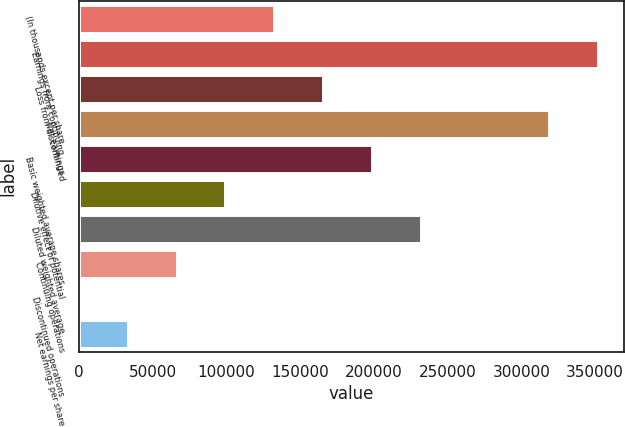Convert chart. <chart><loc_0><loc_0><loc_500><loc_500><bar_chart><fcel>(In thousands except per share<fcel>Earnings from continuing<fcel>Loss from discontinued<fcel>Net earnings<fcel>Basic weighted average shares<fcel>Dilutive effect of potential<fcel>Diluted weighted average<fcel>Continuing operations<fcel>Discontinued operations<fcel>Net earnings per share<nl><fcel>132590<fcel>352170<fcel>165738<fcel>319022<fcel>198886<fcel>99442.9<fcel>232033<fcel>66295.3<fcel>0.1<fcel>33147.7<nl></chart> 